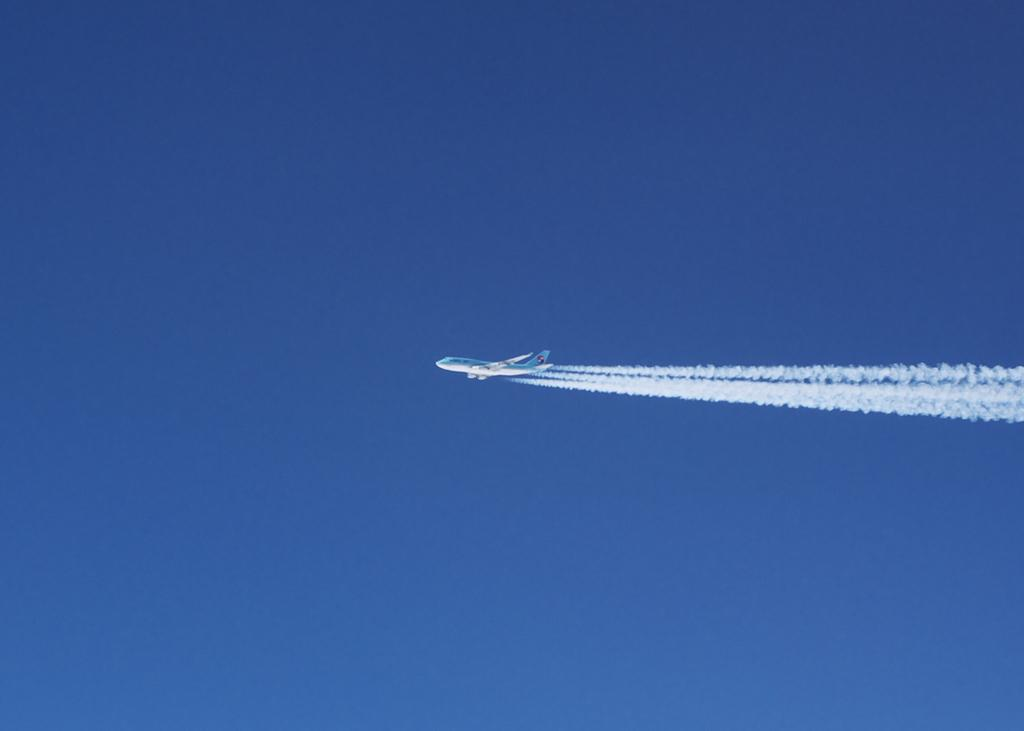Where was the image taken? The image is taken outdoors. What can be seen in the background of the image? There is a sky visible in the background. What is happening in the sky? An airplane is flying in the sky. What is the source of the smoke in the image? The smoke is likely coming from the airplane flying in the sky. What type of orange is being developed in the image? There is no orange present in the image, nor is there any mention of development or agriculture. 